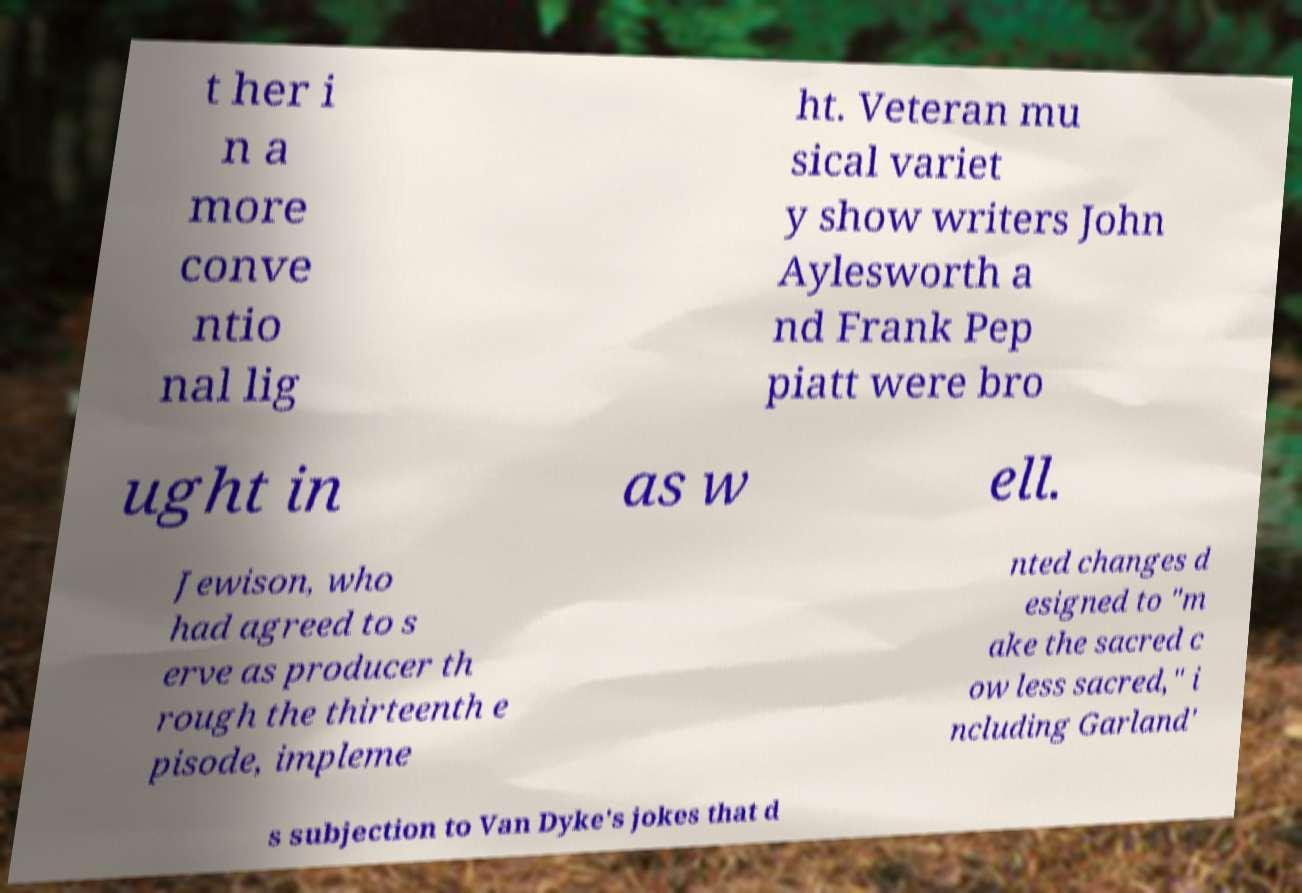Please read and relay the text visible in this image. What does it say? t her i n a more conve ntio nal lig ht. Veteran mu sical variet y show writers John Aylesworth a nd Frank Pep piatt were bro ught in as w ell. Jewison, who had agreed to s erve as producer th rough the thirteenth e pisode, impleme nted changes d esigned to "m ake the sacred c ow less sacred," i ncluding Garland' s subjection to Van Dyke's jokes that d 